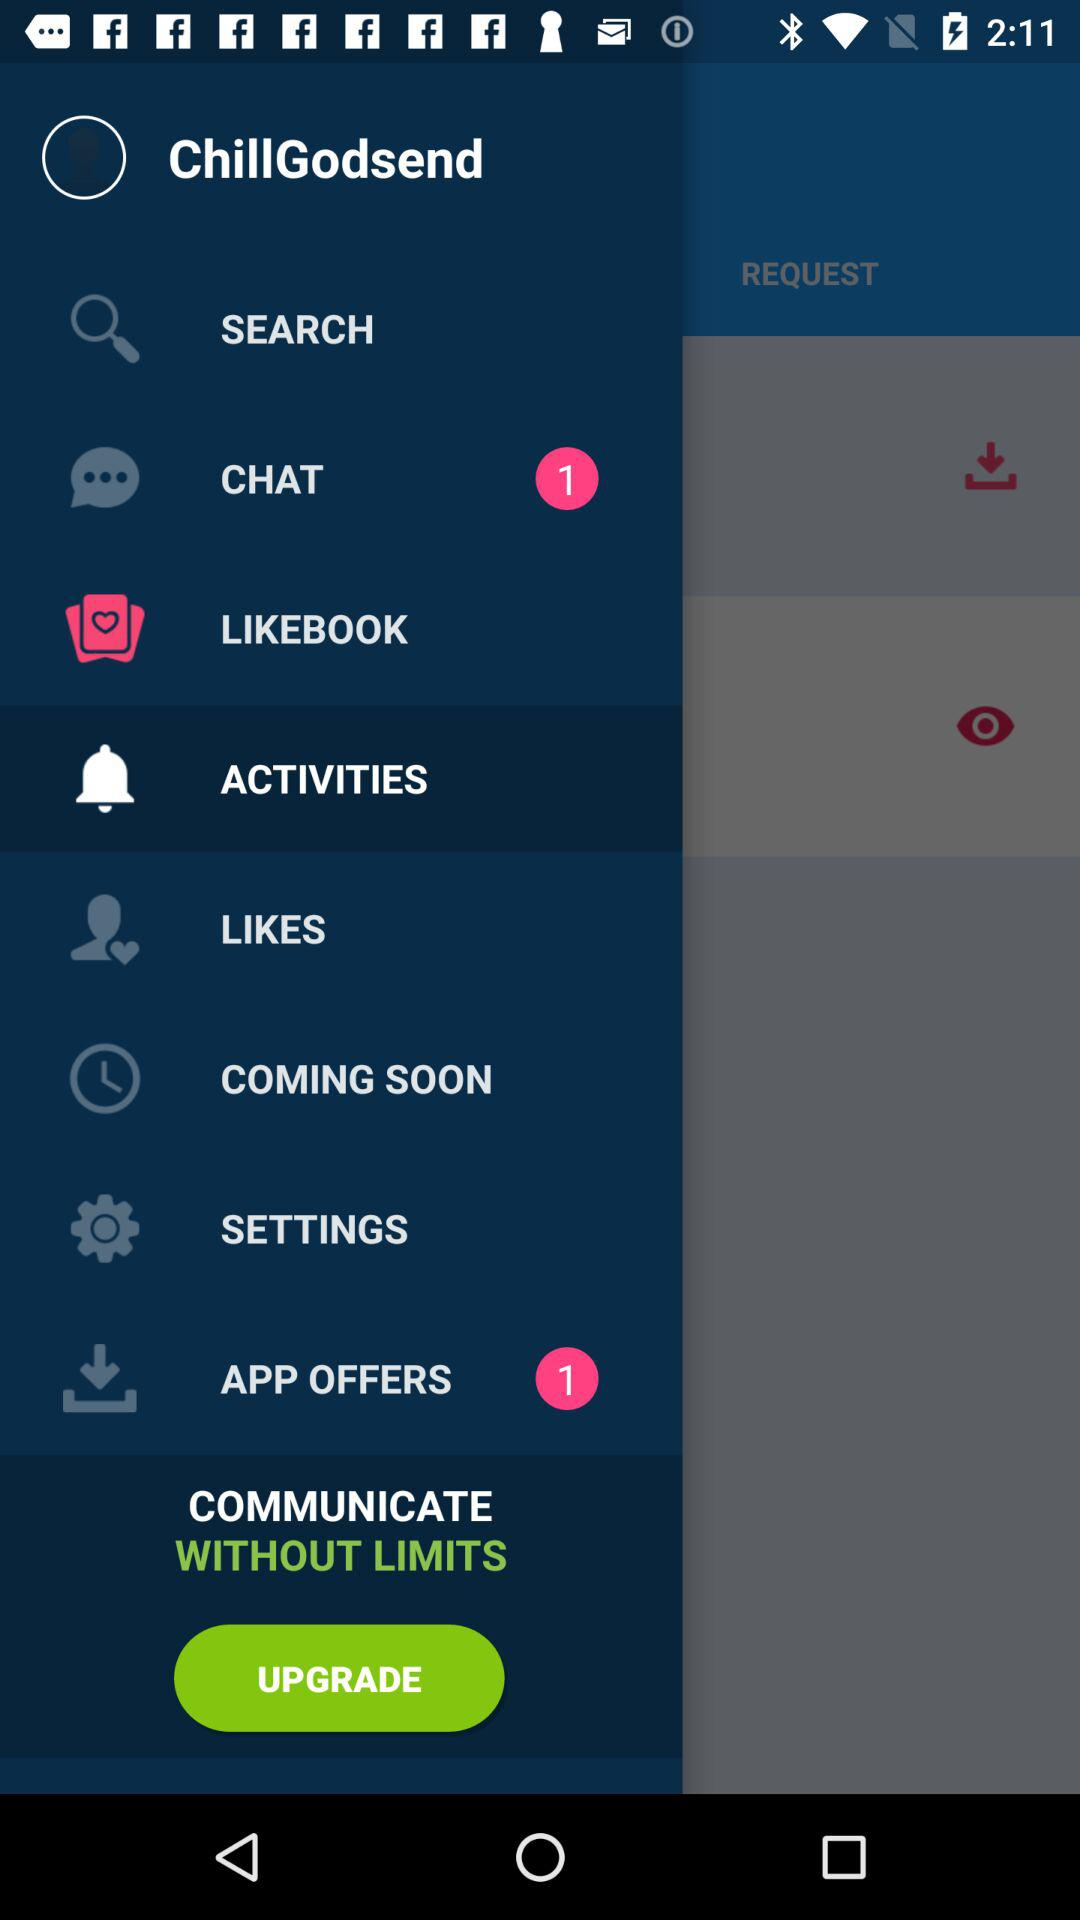How many notifications are pending in "APP OFFERS"? The number of notifications that are pending in "APP OFFERS" is 1. 